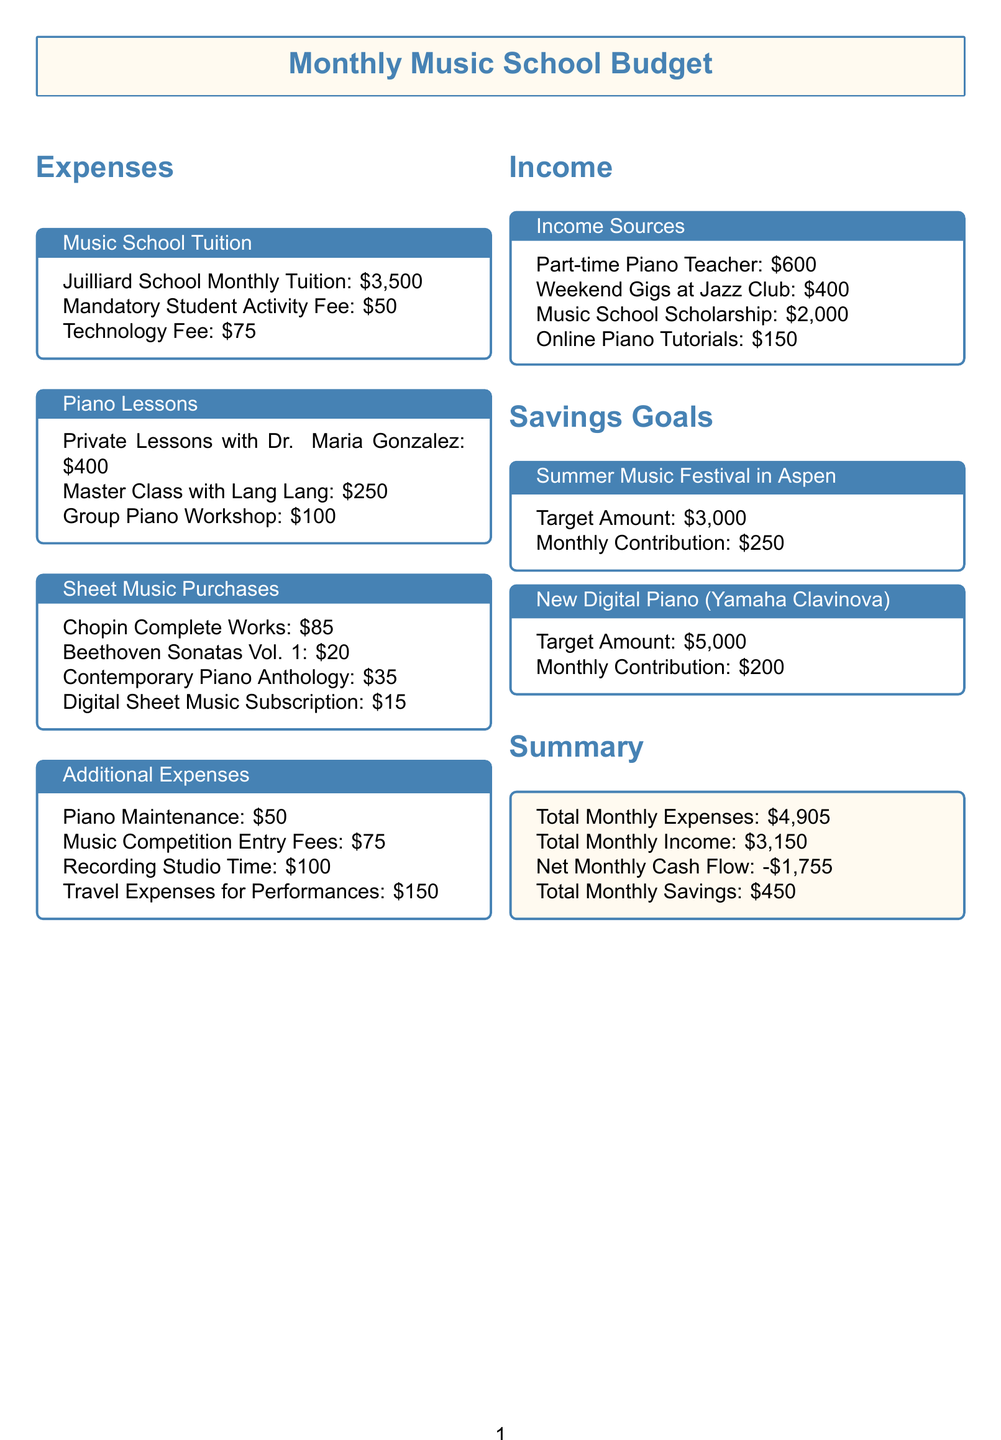What is the total monthly tuition cost? The total monthly tuition cost is calculated by adding the Juilliard School Monthly Tuition, Mandatory Student Activity Fee, and Technology Fee. This totals $3500 + $50 + $75 = $3625.
Answer: $3625 What is the cost of the Digital Sheet Music Subscription? This information is found under the Sheet Music Purchases section. The cost listed for the Digital Sheet Music Subscription is $15.
Answer: $15 How much does the recording studio time cost? The cost of Recording Studio Time is mentioned in the Additional Expenses section, which is $100.
Answer: $100 What is the total cost of piano lessons? The total cost of piano lessons includes Private Lessons with Dr. Maria Gonzalez, Master Class with Lang Lang, and Group Piano Workshop, totaling $400 + $250 + $100 = $750.
Answer: $750 How much is contributed monthly towards the New Digital Piano savings goal? The document states that the monthly contribution towards the New Digital Piano savings goal is $200.
Answer: $200 What is the total monthly income? The total monthly income is the sum of all income sources: $600 + $400 + $2000 + $150 = $3150.
Answer: $3150 What is the net monthly cash flow? The net monthly cash flow is calculated by subtracting total monthly expenses from total monthly income: $3150 - $4905 = -$1755.
Answer: -$1755 What is the target amount for the Summer Music Festival in Aspen? The target amount is specified in the savings goals section as $3000.
Answer: $3000 What is the cost of the Chopin Complete Works? This cost is listed under Sheet Music Purchases and is $85.
Answer: $85 